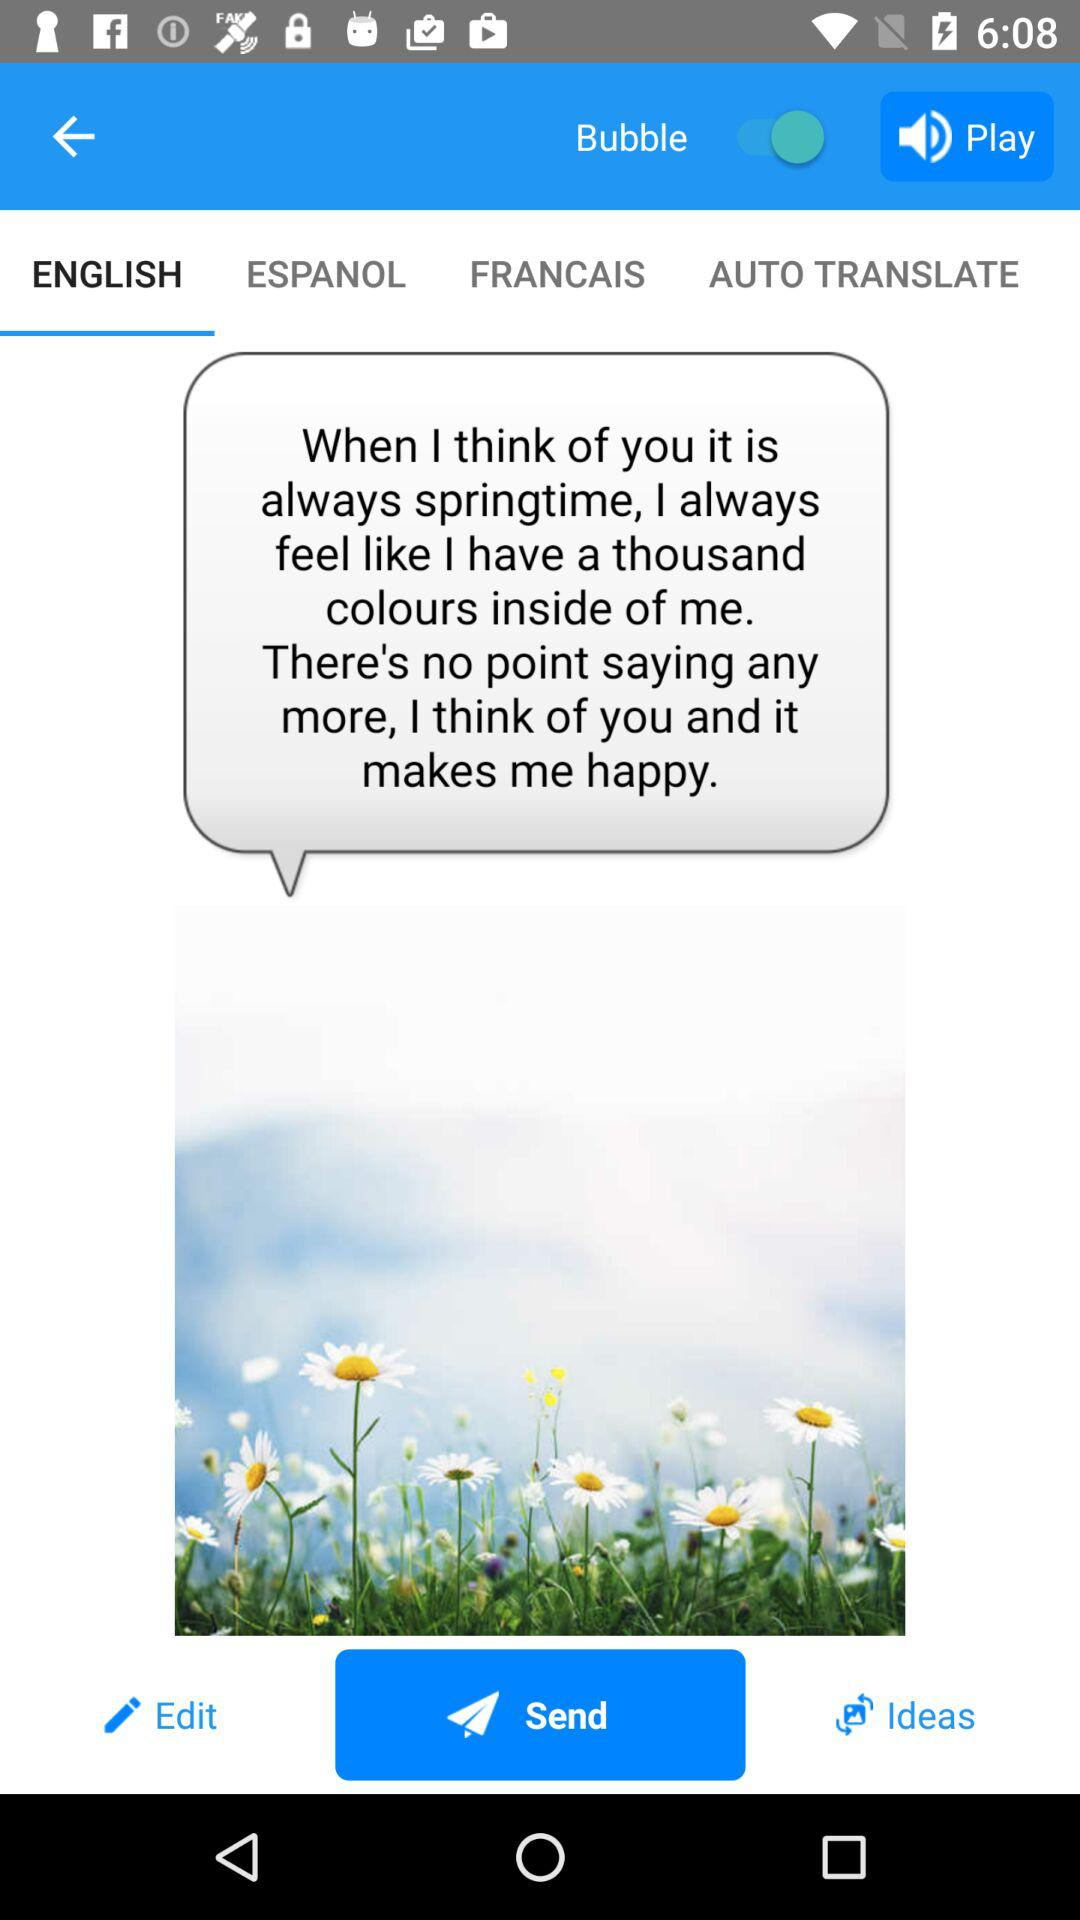Which tab is open? The open tab is "ENGLISH". 